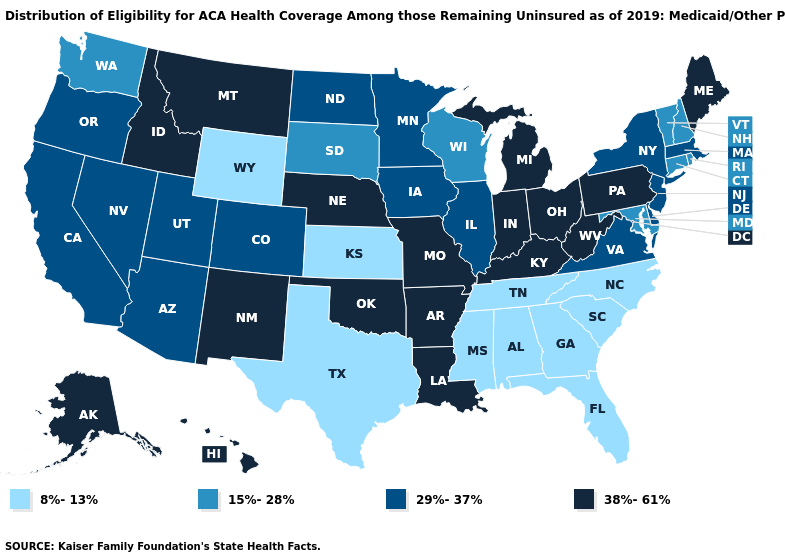Among the states that border Mississippi , does Tennessee have the lowest value?
Concise answer only. Yes. What is the value of Alabama?
Answer briefly. 8%-13%. What is the highest value in the USA?
Short answer required. 38%-61%. What is the value of Washington?
Be succinct. 15%-28%. What is the value of Connecticut?
Short answer required. 15%-28%. Name the states that have a value in the range 29%-37%?
Answer briefly. Arizona, California, Colorado, Delaware, Illinois, Iowa, Massachusetts, Minnesota, Nevada, New Jersey, New York, North Dakota, Oregon, Utah, Virginia. What is the value of Virginia?
Write a very short answer. 29%-37%. What is the value of New Mexico?
Give a very brief answer. 38%-61%. Name the states that have a value in the range 29%-37%?
Quick response, please. Arizona, California, Colorado, Delaware, Illinois, Iowa, Massachusetts, Minnesota, Nevada, New Jersey, New York, North Dakota, Oregon, Utah, Virginia. What is the lowest value in the USA?
Answer briefly. 8%-13%. Does South Dakota have the lowest value in the MidWest?
Give a very brief answer. No. Does Florida have the same value as Tennessee?
Give a very brief answer. Yes. Name the states that have a value in the range 38%-61%?
Answer briefly. Alaska, Arkansas, Hawaii, Idaho, Indiana, Kentucky, Louisiana, Maine, Michigan, Missouri, Montana, Nebraska, New Mexico, Ohio, Oklahoma, Pennsylvania, West Virginia. Does the map have missing data?
Answer briefly. No. What is the value of Indiana?
Be succinct. 38%-61%. 